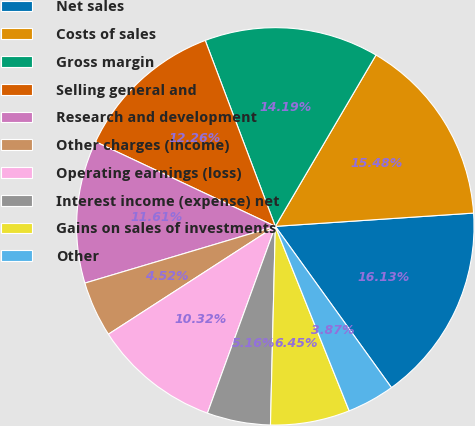Convert chart to OTSL. <chart><loc_0><loc_0><loc_500><loc_500><pie_chart><fcel>Net sales<fcel>Costs of sales<fcel>Gross margin<fcel>Selling general and<fcel>Research and development<fcel>Other charges (income)<fcel>Operating earnings (loss)<fcel>Interest income (expense) net<fcel>Gains on sales of investments<fcel>Other<nl><fcel>16.13%<fcel>15.48%<fcel>14.19%<fcel>12.26%<fcel>11.61%<fcel>4.52%<fcel>10.32%<fcel>5.16%<fcel>6.45%<fcel>3.87%<nl></chart> 